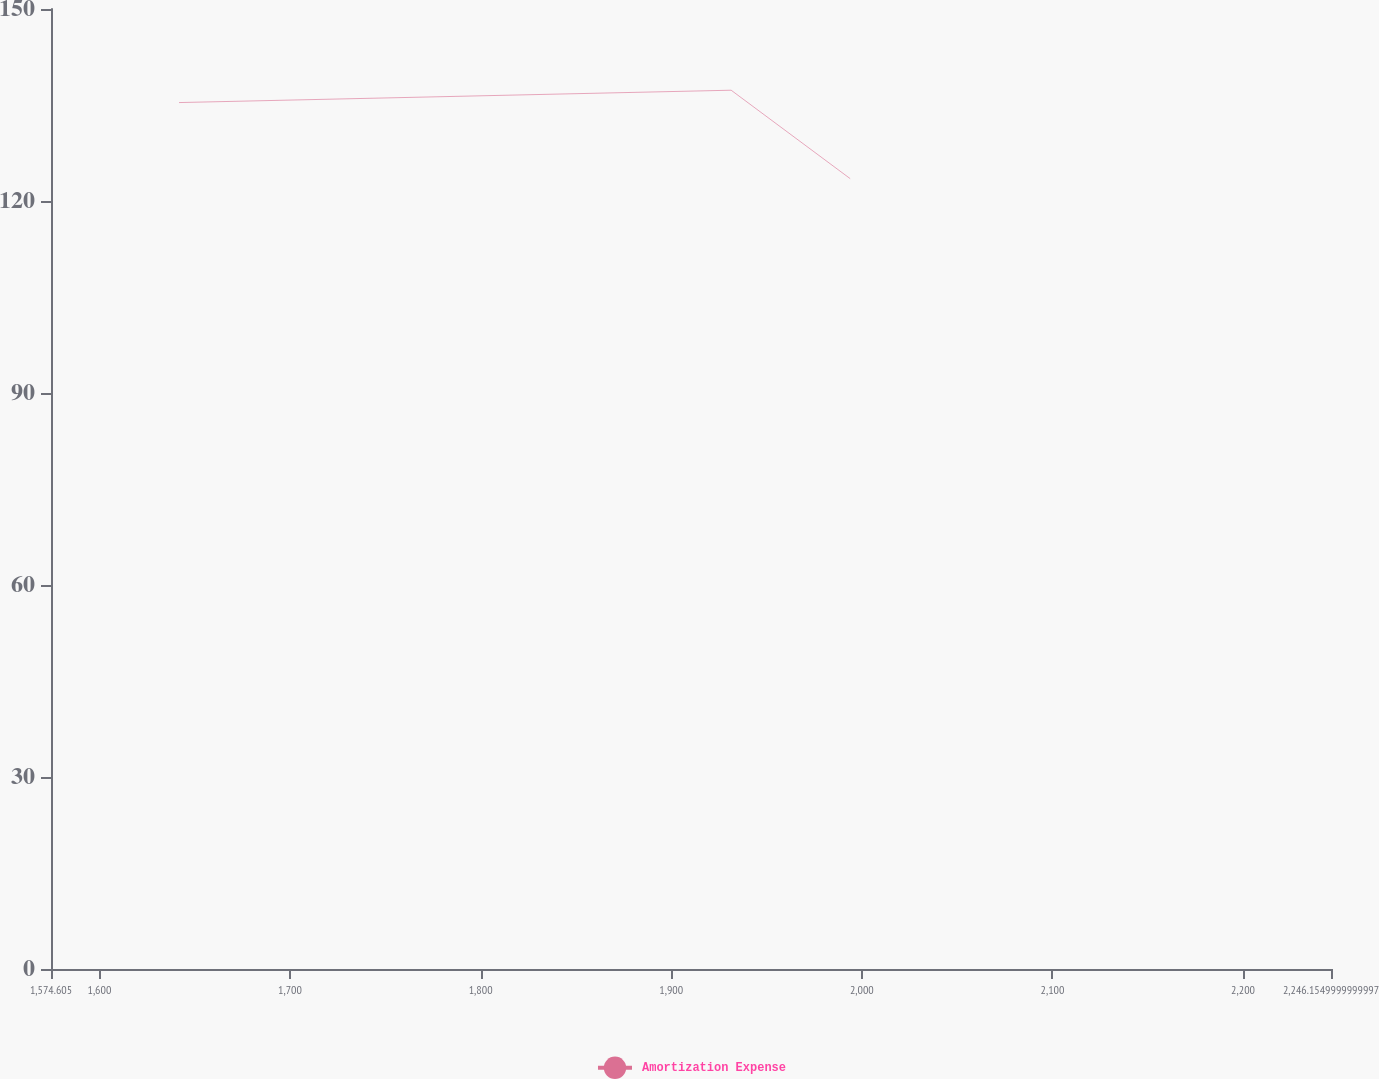<chart> <loc_0><loc_0><loc_500><loc_500><line_chart><ecel><fcel>Amortization Expense<nl><fcel>1641.76<fcel>135.38<nl><fcel>1931.44<fcel>137.31<nl><fcel>1993.91<fcel>123.49<nl><fcel>2250.84<fcel>125.04<nl><fcel>2313.31<fcel>139.04<nl></chart> 